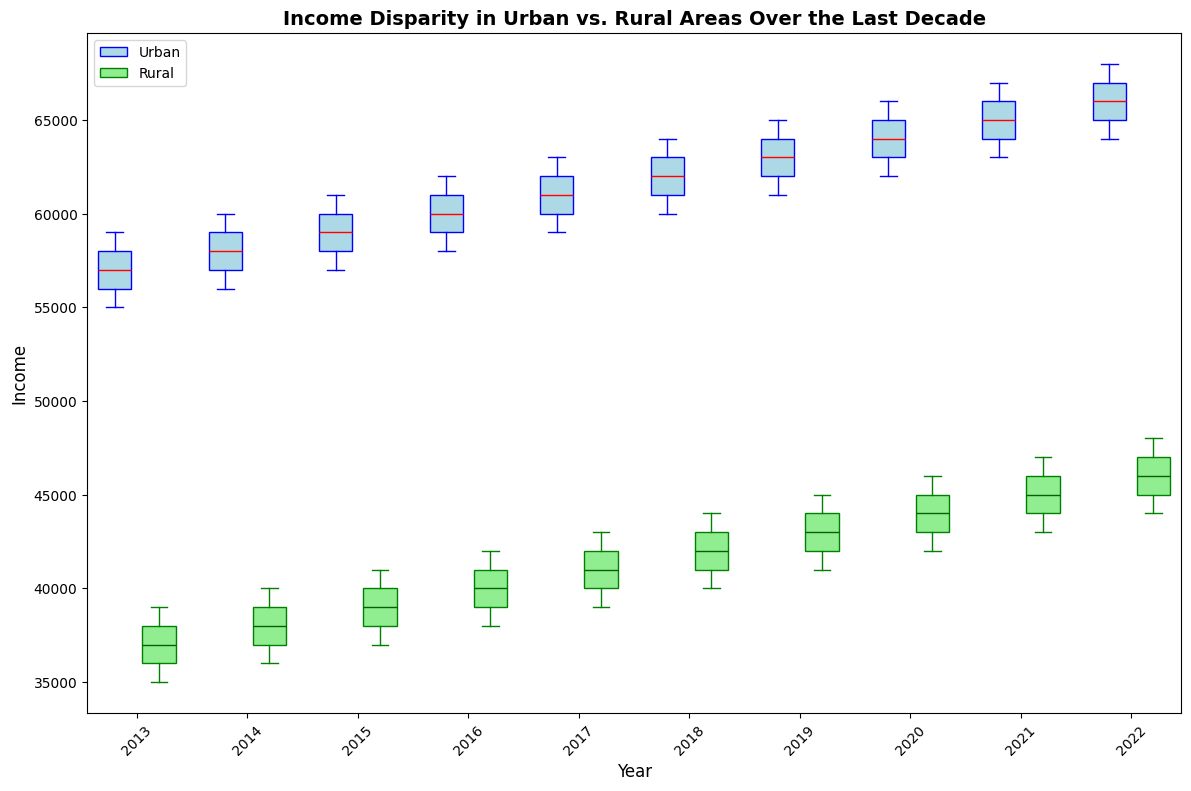What is the general trend of the median income in urban areas over the last decade? Looking at the box plots for urban areas, the median line (red) has consistently increased from 2013 to 2022.
Answer: Upward trend Which year shows the highest median income for rural areas? The highest median line (dark green) for rural areas is visible in the 2022 box plot.
Answer: 2022 How do the income ranges compare between urban and rural areas in 2021? In 2021, the urban area box plot shows a higher general income range (upper bound around $67,000 and lower bound around $63,000) compared to the rural area box plot (upper bound around $47,000 and lower bound around $43,000).
Answer: Urban areas have a higher income range What is the main visible income disparity between urban and rural areas in 2015? The urban median income (red line around $59,000) is significantly higher than the rural median income (dark green line around $39,000) in 2015.
Answer: Urban areas have higher median incomes Are the interquartile ranges (IQRs) wider for urban or rural areas? The IQRs, shown by the height of the box, appear wider for urban areas compared to rural areas in most years.
Answer: Urban areas Which year shows the largest income disparity between urban and rural median incomes? The largest visible gap between the median lines (red for urban and dark green for rural) seems to appear in 2022, where the urban median is much higher.
Answer: 2022 Considering the box plots in 2018, do urban areas have higher variability in income compared to rural areas? Yes, the width of the box plot and spread of the whisker lines indicate greater variability in urban areas for 2018.
Answer: Yes By how much did the median rural income increase from 2013 to 2022? In 2013, the median rural income is around $37,000, and in 2022, it's around $46,000. Therefore, the increase is $46,000 - $37,000 = $9,000.
Answer: $9,000 Which area and year combination shows the lowest minimum income? The lowest minimum income is observed in rural areas for 2013, indicated by the bottom whisker of the rural box plot near $35,000.
Answer: Rural 2013 Are there any years where the median incomes of urban and rural areas are relatively close? In all years shown, the median incomes of urban and rural areas are visibly different with urban consistently higher than rural.
Answer: No 